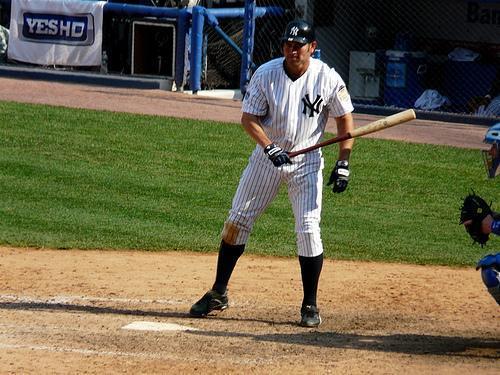How many people are there?
Give a very brief answer. 2. How many zebras are walking across the field?
Give a very brief answer. 0. 